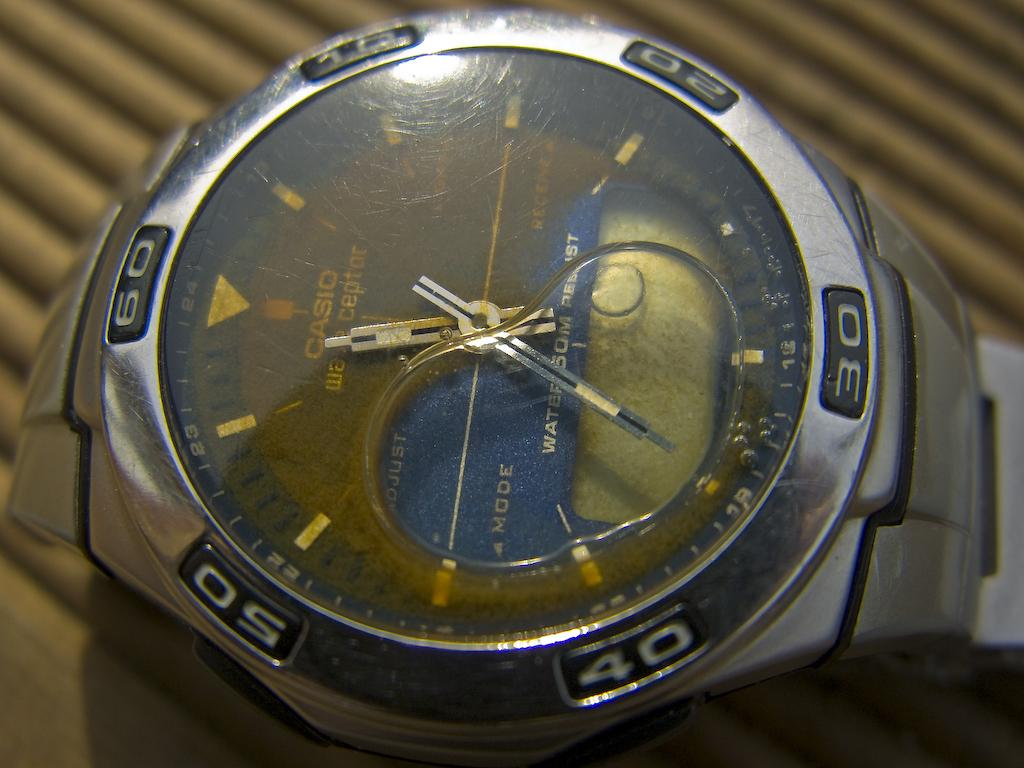<image>
Offer a succinct explanation of the picture presented. A Casio watch  that has the number 50 on it. 